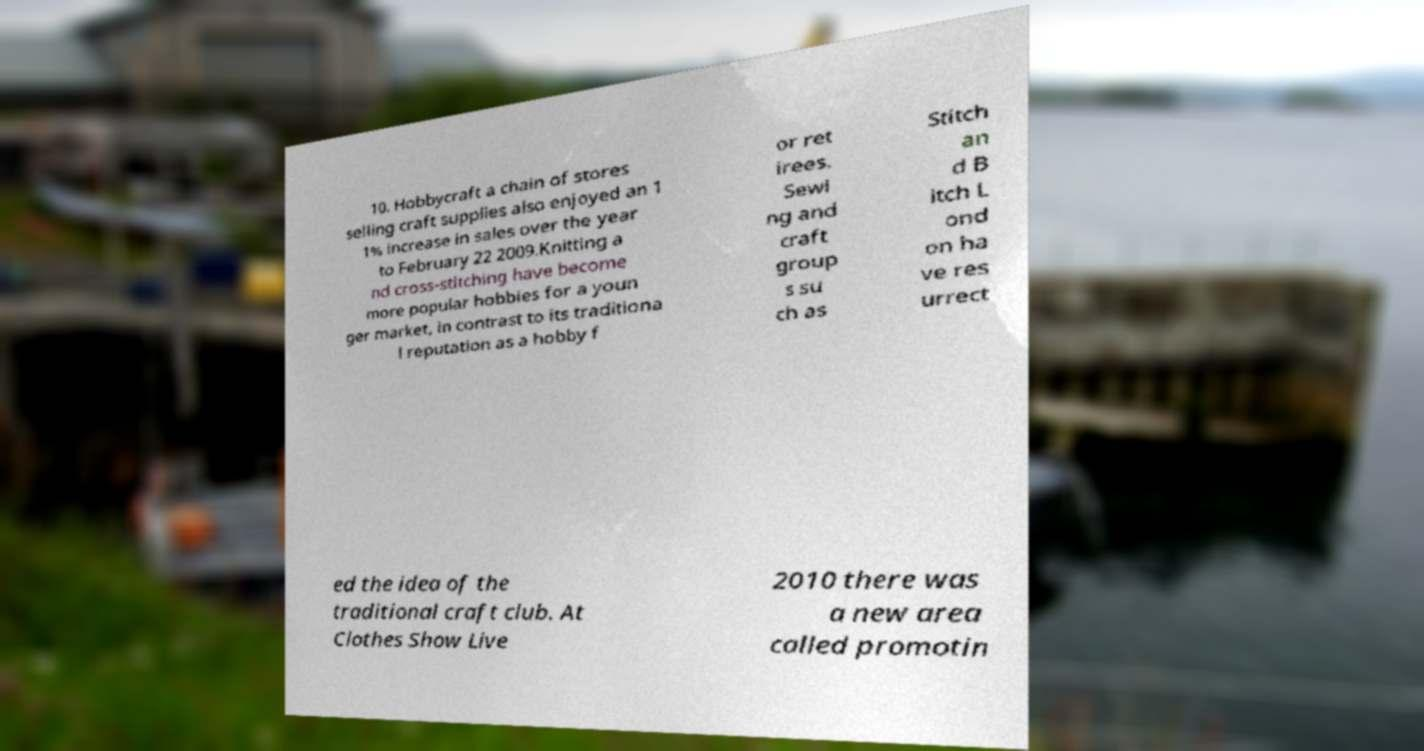Can you read and provide the text displayed in the image?This photo seems to have some interesting text. Can you extract and type it out for me? 10. Hobbycraft a chain of stores selling craft supplies also enjoyed an 1 1% increase in sales over the year to February 22 2009.Knitting a nd cross-stitching have become more popular hobbies for a youn ger market, in contrast to its traditiona l reputation as a hobby f or ret irees. Sewi ng and craft group s su ch as Stitch an d B itch L ond on ha ve res urrect ed the idea of the traditional craft club. At Clothes Show Live 2010 there was a new area called promotin 